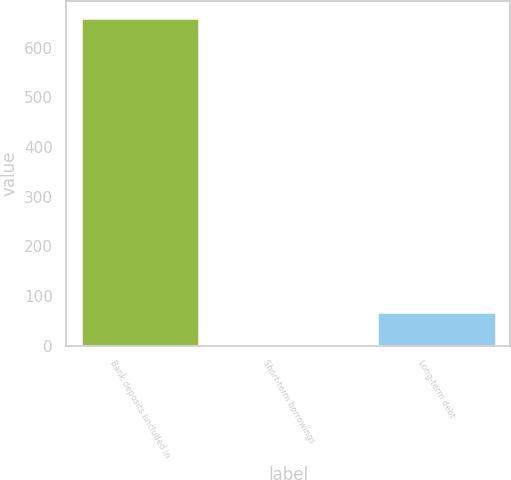Convert chart. <chart><loc_0><loc_0><loc_500><loc_500><bar_chart><fcel>Bank deposits (included in<fcel>Short-term borrowings<fcel>Long-term debt<nl><fcel>660<fcel>2.8<fcel>68.52<nl></chart> 